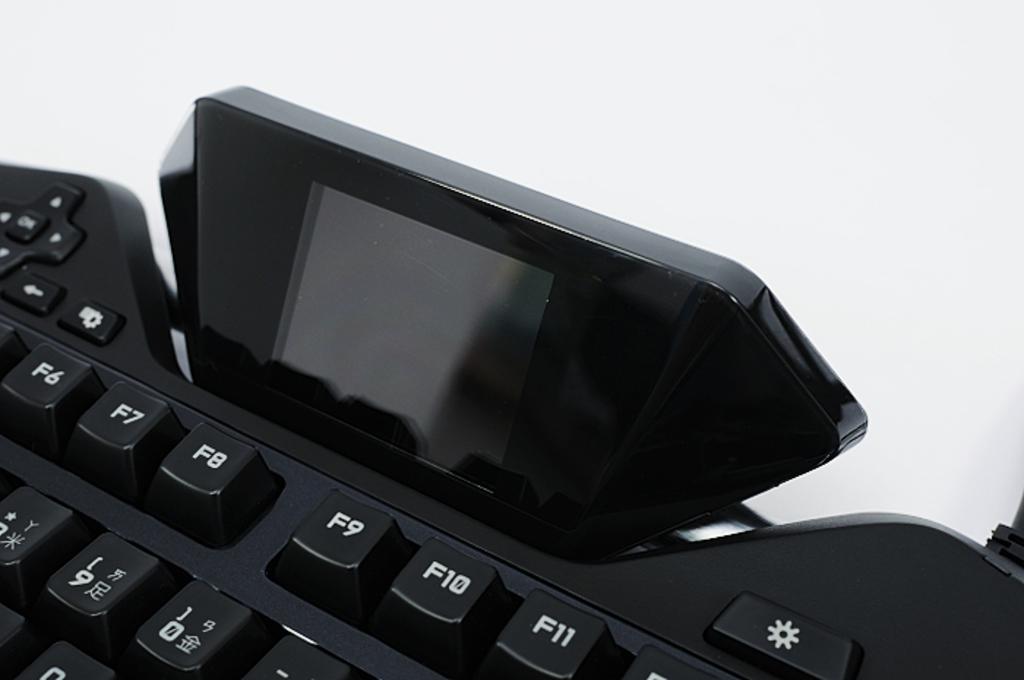What is the last key on the top right?
Offer a very short reply. F11. 